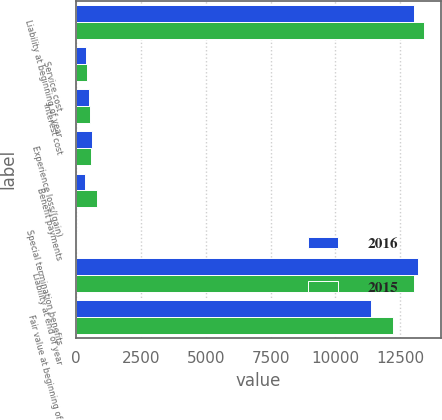Convert chart. <chart><loc_0><loc_0><loc_500><loc_500><stacked_bar_chart><ecel><fcel>Liability at beginning of year<fcel>Service cost<fcel>Interest cost<fcel>Experience loss/(gain)<fcel>Benefit payments<fcel>Special termination benefits<fcel>Liability at end of year<fcel>Fair value at beginning of<nl><fcel>2016<fcel>13033<fcel>393<fcel>484<fcel>614<fcel>347<fcel>11<fcel>13192<fcel>11397<nl><fcel>2015<fcel>13409<fcel>435<fcel>546<fcel>583<fcel>808<fcel>18<fcel>13033<fcel>12224<nl></chart> 